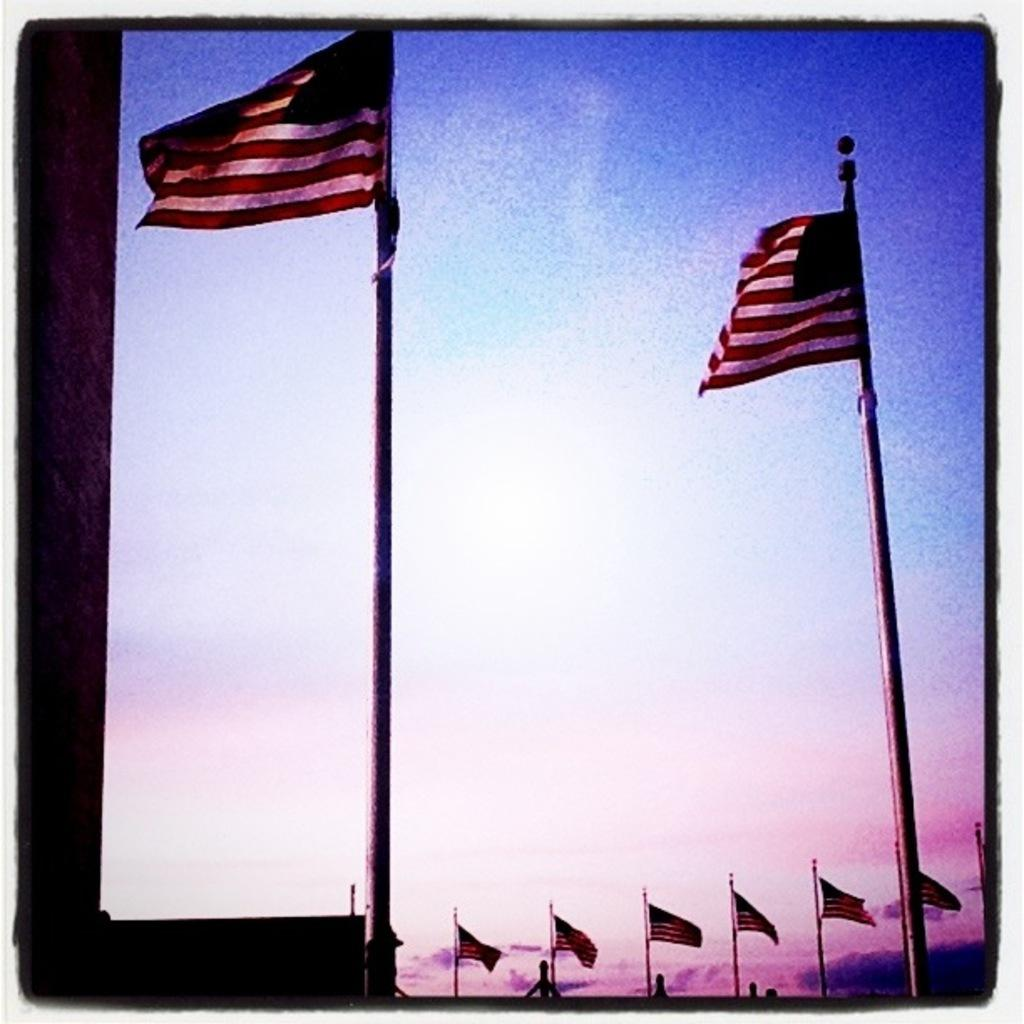What objects are present in the image? There are flags in the image. What can be seen in the background of the image? There is a sky visible in the background of the image. What type of knife is being used to cut the drawer in the image? There is no knife or drawer present in the image; it only features flags and a sky. What reward is being given to the person who found the reward in the image? There is no reward or person searching for it in the image; it only features flags and a sky. 